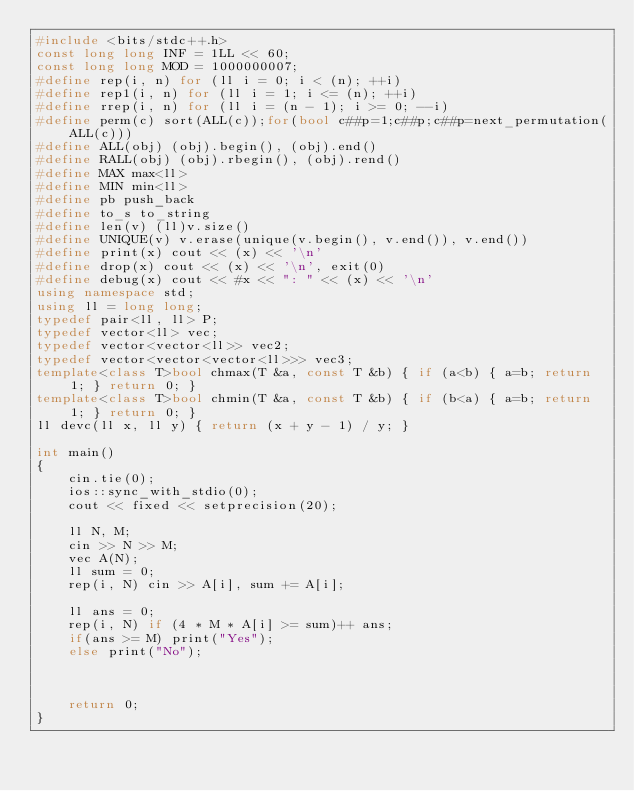Convert code to text. <code><loc_0><loc_0><loc_500><loc_500><_C++_>#include <bits/stdc++.h>
const long long INF = 1LL << 60;
const long long MOD = 1000000007;
#define rep(i, n) for (ll i = 0; i < (n); ++i)
#define rep1(i, n) for (ll i = 1; i <= (n); ++i)
#define rrep(i, n) for (ll i = (n - 1); i >= 0; --i)
#define perm(c) sort(ALL(c));for(bool c##p=1;c##p;c##p=next_permutation(ALL(c)))
#define ALL(obj) (obj).begin(), (obj).end()
#define RALL(obj) (obj).rbegin(), (obj).rend()
#define MAX max<ll>
#define MIN min<ll>
#define pb push_back
#define to_s to_string
#define len(v) (ll)v.size()
#define UNIQUE(v) v.erase(unique(v.begin(), v.end()), v.end())
#define print(x) cout << (x) << '\n'
#define drop(x) cout << (x) << '\n', exit(0)
#define debug(x) cout << #x << ": " << (x) << '\n'
using namespace std;
using ll = long long;
typedef pair<ll, ll> P;
typedef vector<ll> vec;
typedef vector<vector<ll>> vec2;
typedef vector<vector<vector<ll>>> vec3;
template<class T>bool chmax(T &a, const T &b) { if (a<b) { a=b; return 1; } return 0; }
template<class T>bool chmin(T &a, const T &b) { if (b<a) { a=b; return 1; } return 0; }
ll devc(ll x, ll y) { return (x + y - 1) / y; }

int main()
{
    cin.tie(0);
    ios::sync_with_stdio(0);
    cout << fixed << setprecision(20);

    ll N, M;
    cin >> N >> M;
    vec A(N);
    ll sum = 0;
    rep(i, N) cin >> A[i], sum += A[i];

    ll ans = 0;
    rep(i, N) if (4 * M * A[i] >= sum)++ ans;
    if(ans >= M) print("Yes");
    else print("No");



    return 0;
}</code> 